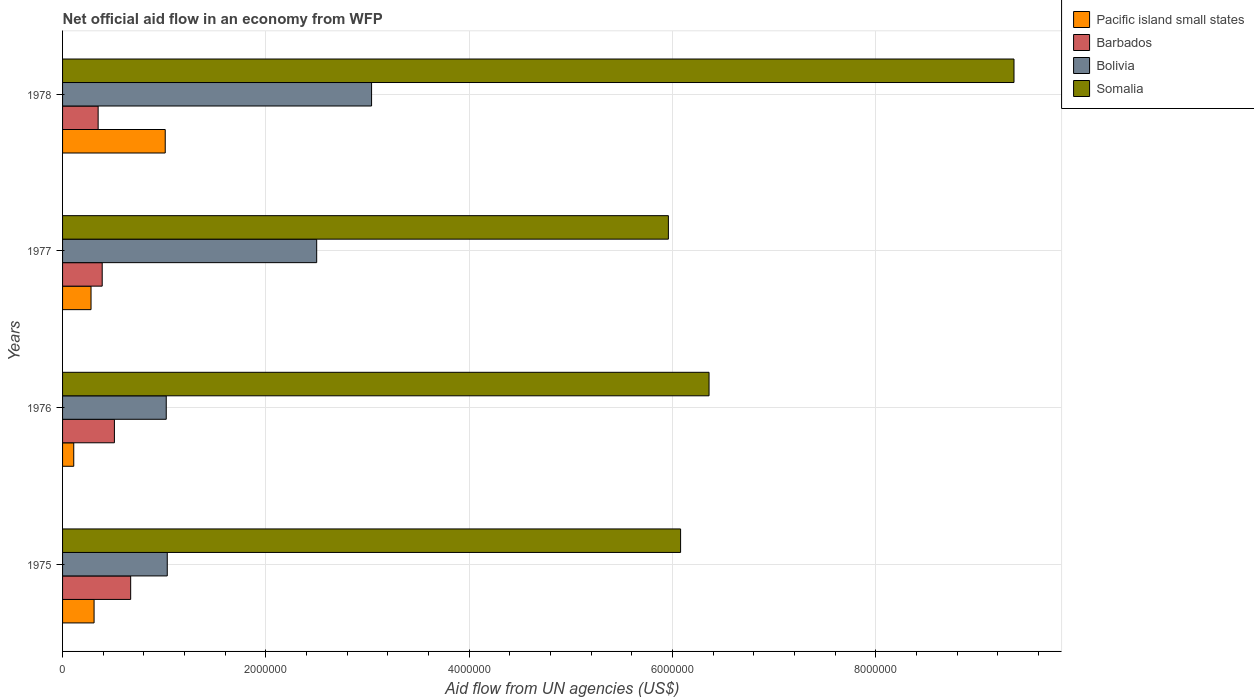How many different coloured bars are there?
Ensure brevity in your answer.  4. How many groups of bars are there?
Give a very brief answer. 4. How many bars are there on the 1st tick from the top?
Offer a very short reply. 4. How many bars are there on the 4th tick from the bottom?
Offer a terse response. 4. What is the label of the 1st group of bars from the top?
Offer a very short reply. 1978. In how many cases, is the number of bars for a given year not equal to the number of legend labels?
Your answer should be very brief. 0. What is the net official aid flow in Bolivia in 1978?
Ensure brevity in your answer.  3.04e+06. Across all years, what is the maximum net official aid flow in Somalia?
Offer a terse response. 9.36e+06. In which year was the net official aid flow in Barbados maximum?
Give a very brief answer. 1975. In which year was the net official aid flow in Pacific island small states minimum?
Provide a succinct answer. 1976. What is the total net official aid flow in Bolivia in the graph?
Ensure brevity in your answer.  7.59e+06. What is the difference between the net official aid flow in Barbados in 1975 and the net official aid flow in Bolivia in 1976?
Keep it short and to the point. -3.50e+05. What is the average net official aid flow in Bolivia per year?
Offer a terse response. 1.90e+06. In the year 1976, what is the difference between the net official aid flow in Bolivia and net official aid flow in Pacific island small states?
Offer a very short reply. 9.10e+05. In how many years, is the net official aid flow in Bolivia greater than 1200000 US$?
Ensure brevity in your answer.  2. What is the ratio of the net official aid flow in Somalia in 1975 to that in 1976?
Keep it short and to the point. 0.96. Is the difference between the net official aid flow in Bolivia in 1976 and 1977 greater than the difference between the net official aid flow in Pacific island small states in 1976 and 1977?
Ensure brevity in your answer.  No. What is the difference between the highest and the second highest net official aid flow in Bolivia?
Provide a succinct answer. 5.40e+05. What is the difference between the highest and the lowest net official aid flow in Bolivia?
Your answer should be compact. 2.02e+06. What does the 1st bar from the top in 1977 represents?
Your answer should be very brief. Somalia. What does the 4th bar from the bottom in 1976 represents?
Offer a terse response. Somalia. Is it the case that in every year, the sum of the net official aid flow in Somalia and net official aid flow in Barbados is greater than the net official aid flow in Pacific island small states?
Give a very brief answer. Yes. How many bars are there?
Provide a short and direct response. 16. How many years are there in the graph?
Provide a short and direct response. 4. What is the difference between two consecutive major ticks on the X-axis?
Provide a succinct answer. 2.00e+06. Does the graph contain grids?
Your answer should be very brief. Yes. How many legend labels are there?
Keep it short and to the point. 4. How are the legend labels stacked?
Give a very brief answer. Vertical. What is the title of the graph?
Your answer should be compact. Net official aid flow in an economy from WFP. What is the label or title of the X-axis?
Give a very brief answer. Aid flow from UN agencies (US$). What is the label or title of the Y-axis?
Make the answer very short. Years. What is the Aid flow from UN agencies (US$) of Barbados in 1975?
Your response must be concise. 6.70e+05. What is the Aid flow from UN agencies (US$) in Bolivia in 1975?
Make the answer very short. 1.03e+06. What is the Aid flow from UN agencies (US$) in Somalia in 1975?
Provide a short and direct response. 6.08e+06. What is the Aid flow from UN agencies (US$) of Barbados in 1976?
Ensure brevity in your answer.  5.10e+05. What is the Aid flow from UN agencies (US$) of Bolivia in 1976?
Offer a terse response. 1.02e+06. What is the Aid flow from UN agencies (US$) of Somalia in 1976?
Offer a terse response. 6.36e+06. What is the Aid flow from UN agencies (US$) of Barbados in 1977?
Keep it short and to the point. 3.90e+05. What is the Aid flow from UN agencies (US$) of Bolivia in 1977?
Your response must be concise. 2.50e+06. What is the Aid flow from UN agencies (US$) in Somalia in 1977?
Your response must be concise. 5.96e+06. What is the Aid flow from UN agencies (US$) in Pacific island small states in 1978?
Offer a terse response. 1.01e+06. What is the Aid flow from UN agencies (US$) in Bolivia in 1978?
Offer a terse response. 3.04e+06. What is the Aid flow from UN agencies (US$) of Somalia in 1978?
Offer a terse response. 9.36e+06. Across all years, what is the maximum Aid flow from UN agencies (US$) in Pacific island small states?
Provide a short and direct response. 1.01e+06. Across all years, what is the maximum Aid flow from UN agencies (US$) in Barbados?
Your response must be concise. 6.70e+05. Across all years, what is the maximum Aid flow from UN agencies (US$) in Bolivia?
Give a very brief answer. 3.04e+06. Across all years, what is the maximum Aid flow from UN agencies (US$) in Somalia?
Keep it short and to the point. 9.36e+06. Across all years, what is the minimum Aid flow from UN agencies (US$) of Bolivia?
Your answer should be compact. 1.02e+06. Across all years, what is the minimum Aid flow from UN agencies (US$) in Somalia?
Offer a terse response. 5.96e+06. What is the total Aid flow from UN agencies (US$) of Pacific island small states in the graph?
Give a very brief answer. 1.71e+06. What is the total Aid flow from UN agencies (US$) in Barbados in the graph?
Ensure brevity in your answer.  1.92e+06. What is the total Aid flow from UN agencies (US$) of Bolivia in the graph?
Offer a very short reply. 7.59e+06. What is the total Aid flow from UN agencies (US$) in Somalia in the graph?
Provide a short and direct response. 2.78e+07. What is the difference between the Aid flow from UN agencies (US$) of Pacific island small states in 1975 and that in 1976?
Your answer should be very brief. 2.00e+05. What is the difference between the Aid flow from UN agencies (US$) in Somalia in 1975 and that in 1976?
Your answer should be very brief. -2.80e+05. What is the difference between the Aid flow from UN agencies (US$) of Bolivia in 1975 and that in 1977?
Your answer should be compact. -1.47e+06. What is the difference between the Aid flow from UN agencies (US$) of Pacific island small states in 1975 and that in 1978?
Offer a very short reply. -7.00e+05. What is the difference between the Aid flow from UN agencies (US$) of Barbados in 1975 and that in 1978?
Offer a terse response. 3.20e+05. What is the difference between the Aid flow from UN agencies (US$) of Bolivia in 1975 and that in 1978?
Provide a succinct answer. -2.01e+06. What is the difference between the Aid flow from UN agencies (US$) in Somalia in 1975 and that in 1978?
Make the answer very short. -3.28e+06. What is the difference between the Aid flow from UN agencies (US$) in Bolivia in 1976 and that in 1977?
Your answer should be compact. -1.48e+06. What is the difference between the Aid flow from UN agencies (US$) of Somalia in 1976 and that in 1977?
Provide a short and direct response. 4.00e+05. What is the difference between the Aid flow from UN agencies (US$) of Pacific island small states in 1976 and that in 1978?
Make the answer very short. -9.00e+05. What is the difference between the Aid flow from UN agencies (US$) in Barbados in 1976 and that in 1978?
Offer a terse response. 1.60e+05. What is the difference between the Aid flow from UN agencies (US$) in Bolivia in 1976 and that in 1978?
Your response must be concise. -2.02e+06. What is the difference between the Aid flow from UN agencies (US$) in Pacific island small states in 1977 and that in 1978?
Your answer should be compact. -7.30e+05. What is the difference between the Aid flow from UN agencies (US$) in Bolivia in 1977 and that in 1978?
Your response must be concise. -5.40e+05. What is the difference between the Aid flow from UN agencies (US$) of Somalia in 1977 and that in 1978?
Your answer should be very brief. -3.40e+06. What is the difference between the Aid flow from UN agencies (US$) in Pacific island small states in 1975 and the Aid flow from UN agencies (US$) in Bolivia in 1976?
Offer a very short reply. -7.10e+05. What is the difference between the Aid flow from UN agencies (US$) in Pacific island small states in 1975 and the Aid flow from UN agencies (US$) in Somalia in 1976?
Your answer should be very brief. -6.05e+06. What is the difference between the Aid flow from UN agencies (US$) of Barbados in 1975 and the Aid flow from UN agencies (US$) of Bolivia in 1976?
Offer a very short reply. -3.50e+05. What is the difference between the Aid flow from UN agencies (US$) in Barbados in 1975 and the Aid flow from UN agencies (US$) in Somalia in 1976?
Provide a short and direct response. -5.69e+06. What is the difference between the Aid flow from UN agencies (US$) of Bolivia in 1975 and the Aid flow from UN agencies (US$) of Somalia in 1976?
Make the answer very short. -5.33e+06. What is the difference between the Aid flow from UN agencies (US$) in Pacific island small states in 1975 and the Aid flow from UN agencies (US$) in Bolivia in 1977?
Offer a very short reply. -2.19e+06. What is the difference between the Aid flow from UN agencies (US$) of Pacific island small states in 1975 and the Aid flow from UN agencies (US$) of Somalia in 1977?
Your response must be concise. -5.65e+06. What is the difference between the Aid flow from UN agencies (US$) of Barbados in 1975 and the Aid flow from UN agencies (US$) of Bolivia in 1977?
Offer a very short reply. -1.83e+06. What is the difference between the Aid flow from UN agencies (US$) of Barbados in 1975 and the Aid flow from UN agencies (US$) of Somalia in 1977?
Make the answer very short. -5.29e+06. What is the difference between the Aid flow from UN agencies (US$) in Bolivia in 1975 and the Aid flow from UN agencies (US$) in Somalia in 1977?
Ensure brevity in your answer.  -4.93e+06. What is the difference between the Aid flow from UN agencies (US$) of Pacific island small states in 1975 and the Aid flow from UN agencies (US$) of Bolivia in 1978?
Make the answer very short. -2.73e+06. What is the difference between the Aid flow from UN agencies (US$) of Pacific island small states in 1975 and the Aid flow from UN agencies (US$) of Somalia in 1978?
Ensure brevity in your answer.  -9.05e+06. What is the difference between the Aid flow from UN agencies (US$) of Barbados in 1975 and the Aid flow from UN agencies (US$) of Bolivia in 1978?
Provide a short and direct response. -2.37e+06. What is the difference between the Aid flow from UN agencies (US$) in Barbados in 1975 and the Aid flow from UN agencies (US$) in Somalia in 1978?
Your response must be concise. -8.69e+06. What is the difference between the Aid flow from UN agencies (US$) in Bolivia in 1975 and the Aid flow from UN agencies (US$) in Somalia in 1978?
Provide a succinct answer. -8.33e+06. What is the difference between the Aid flow from UN agencies (US$) in Pacific island small states in 1976 and the Aid flow from UN agencies (US$) in Barbados in 1977?
Your response must be concise. -2.80e+05. What is the difference between the Aid flow from UN agencies (US$) in Pacific island small states in 1976 and the Aid flow from UN agencies (US$) in Bolivia in 1977?
Offer a very short reply. -2.39e+06. What is the difference between the Aid flow from UN agencies (US$) of Pacific island small states in 1976 and the Aid flow from UN agencies (US$) of Somalia in 1977?
Your answer should be compact. -5.85e+06. What is the difference between the Aid flow from UN agencies (US$) in Barbados in 1976 and the Aid flow from UN agencies (US$) in Bolivia in 1977?
Keep it short and to the point. -1.99e+06. What is the difference between the Aid flow from UN agencies (US$) of Barbados in 1976 and the Aid flow from UN agencies (US$) of Somalia in 1977?
Provide a short and direct response. -5.45e+06. What is the difference between the Aid flow from UN agencies (US$) of Bolivia in 1976 and the Aid flow from UN agencies (US$) of Somalia in 1977?
Offer a very short reply. -4.94e+06. What is the difference between the Aid flow from UN agencies (US$) in Pacific island small states in 1976 and the Aid flow from UN agencies (US$) in Bolivia in 1978?
Offer a terse response. -2.93e+06. What is the difference between the Aid flow from UN agencies (US$) in Pacific island small states in 1976 and the Aid flow from UN agencies (US$) in Somalia in 1978?
Your answer should be very brief. -9.25e+06. What is the difference between the Aid flow from UN agencies (US$) in Barbados in 1976 and the Aid flow from UN agencies (US$) in Bolivia in 1978?
Your answer should be very brief. -2.53e+06. What is the difference between the Aid flow from UN agencies (US$) in Barbados in 1976 and the Aid flow from UN agencies (US$) in Somalia in 1978?
Offer a very short reply. -8.85e+06. What is the difference between the Aid flow from UN agencies (US$) in Bolivia in 1976 and the Aid flow from UN agencies (US$) in Somalia in 1978?
Your response must be concise. -8.34e+06. What is the difference between the Aid flow from UN agencies (US$) in Pacific island small states in 1977 and the Aid flow from UN agencies (US$) in Bolivia in 1978?
Keep it short and to the point. -2.76e+06. What is the difference between the Aid flow from UN agencies (US$) in Pacific island small states in 1977 and the Aid flow from UN agencies (US$) in Somalia in 1978?
Your answer should be very brief. -9.08e+06. What is the difference between the Aid flow from UN agencies (US$) of Barbados in 1977 and the Aid flow from UN agencies (US$) of Bolivia in 1978?
Your answer should be very brief. -2.65e+06. What is the difference between the Aid flow from UN agencies (US$) in Barbados in 1977 and the Aid flow from UN agencies (US$) in Somalia in 1978?
Give a very brief answer. -8.97e+06. What is the difference between the Aid flow from UN agencies (US$) of Bolivia in 1977 and the Aid flow from UN agencies (US$) of Somalia in 1978?
Your response must be concise. -6.86e+06. What is the average Aid flow from UN agencies (US$) of Pacific island small states per year?
Provide a succinct answer. 4.28e+05. What is the average Aid flow from UN agencies (US$) in Bolivia per year?
Ensure brevity in your answer.  1.90e+06. What is the average Aid flow from UN agencies (US$) of Somalia per year?
Give a very brief answer. 6.94e+06. In the year 1975, what is the difference between the Aid flow from UN agencies (US$) of Pacific island small states and Aid flow from UN agencies (US$) of Barbados?
Make the answer very short. -3.60e+05. In the year 1975, what is the difference between the Aid flow from UN agencies (US$) of Pacific island small states and Aid flow from UN agencies (US$) of Bolivia?
Your response must be concise. -7.20e+05. In the year 1975, what is the difference between the Aid flow from UN agencies (US$) in Pacific island small states and Aid flow from UN agencies (US$) in Somalia?
Ensure brevity in your answer.  -5.77e+06. In the year 1975, what is the difference between the Aid flow from UN agencies (US$) of Barbados and Aid flow from UN agencies (US$) of Bolivia?
Your response must be concise. -3.60e+05. In the year 1975, what is the difference between the Aid flow from UN agencies (US$) of Barbados and Aid flow from UN agencies (US$) of Somalia?
Make the answer very short. -5.41e+06. In the year 1975, what is the difference between the Aid flow from UN agencies (US$) of Bolivia and Aid flow from UN agencies (US$) of Somalia?
Make the answer very short. -5.05e+06. In the year 1976, what is the difference between the Aid flow from UN agencies (US$) of Pacific island small states and Aid flow from UN agencies (US$) of Barbados?
Make the answer very short. -4.00e+05. In the year 1976, what is the difference between the Aid flow from UN agencies (US$) in Pacific island small states and Aid flow from UN agencies (US$) in Bolivia?
Ensure brevity in your answer.  -9.10e+05. In the year 1976, what is the difference between the Aid flow from UN agencies (US$) of Pacific island small states and Aid flow from UN agencies (US$) of Somalia?
Ensure brevity in your answer.  -6.25e+06. In the year 1976, what is the difference between the Aid flow from UN agencies (US$) in Barbados and Aid flow from UN agencies (US$) in Bolivia?
Your answer should be compact. -5.10e+05. In the year 1976, what is the difference between the Aid flow from UN agencies (US$) of Barbados and Aid flow from UN agencies (US$) of Somalia?
Your answer should be compact. -5.85e+06. In the year 1976, what is the difference between the Aid flow from UN agencies (US$) of Bolivia and Aid flow from UN agencies (US$) of Somalia?
Keep it short and to the point. -5.34e+06. In the year 1977, what is the difference between the Aid flow from UN agencies (US$) in Pacific island small states and Aid flow from UN agencies (US$) in Barbados?
Provide a succinct answer. -1.10e+05. In the year 1977, what is the difference between the Aid flow from UN agencies (US$) of Pacific island small states and Aid flow from UN agencies (US$) of Bolivia?
Offer a terse response. -2.22e+06. In the year 1977, what is the difference between the Aid flow from UN agencies (US$) of Pacific island small states and Aid flow from UN agencies (US$) of Somalia?
Give a very brief answer. -5.68e+06. In the year 1977, what is the difference between the Aid flow from UN agencies (US$) of Barbados and Aid flow from UN agencies (US$) of Bolivia?
Give a very brief answer. -2.11e+06. In the year 1977, what is the difference between the Aid flow from UN agencies (US$) of Barbados and Aid flow from UN agencies (US$) of Somalia?
Your response must be concise. -5.57e+06. In the year 1977, what is the difference between the Aid flow from UN agencies (US$) of Bolivia and Aid flow from UN agencies (US$) of Somalia?
Provide a short and direct response. -3.46e+06. In the year 1978, what is the difference between the Aid flow from UN agencies (US$) in Pacific island small states and Aid flow from UN agencies (US$) in Bolivia?
Keep it short and to the point. -2.03e+06. In the year 1978, what is the difference between the Aid flow from UN agencies (US$) in Pacific island small states and Aid flow from UN agencies (US$) in Somalia?
Provide a succinct answer. -8.35e+06. In the year 1978, what is the difference between the Aid flow from UN agencies (US$) in Barbados and Aid flow from UN agencies (US$) in Bolivia?
Offer a terse response. -2.69e+06. In the year 1978, what is the difference between the Aid flow from UN agencies (US$) of Barbados and Aid flow from UN agencies (US$) of Somalia?
Ensure brevity in your answer.  -9.01e+06. In the year 1978, what is the difference between the Aid flow from UN agencies (US$) in Bolivia and Aid flow from UN agencies (US$) in Somalia?
Ensure brevity in your answer.  -6.32e+06. What is the ratio of the Aid flow from UN agencies (US$) in Pacific island small states in 1975 to that in 1976?
Provide a short and direct response. 2.82. What is the ratio of the Aid flow from UN agencies (US$) of Barbados in 1975 to that in 1976?
Provide a succinct answer. 1.31. What is the ratio of the Aid flow from UN agencies (US$) of Bolivia in 1975 to that in 1976?
Your response must be concise. 1.01. What is the ratio of the Aid flow from UN agencies (US$) of Somalia in 1975 to that in 1976?
Your response must be concise. 0.96. What is the ratio of the Aid flow from UN agencies (US$) of Pacific island small states in 1975 to that in 1977?
Give a very brief answer. 1.11. What is the ratio of the Aid flow from UN agencies (US$) of Barbados in 1975 to that in 1977?
Make the answer very short. 1.72. What is the ratio of the Aid flow from UN agencies (US$) in Bolivia in 1975 to that in 1977?
Keep it short and to the point. 0.41. What is the ratio of the Aid flow from UN agencies (US$) of Somalia in 1975 to that in 1977?
Make the answer very short. 1.02. What is the ratio of the Aid flow from UN agencies (US$) in Pacific island small states in 1975 to that in 1978?
Your response must be concise. 0.31. What is the ratio of the Aid flow from UN agencies (US$) in Barbados in 1975 to that in 1978?
Your response must be concise. 1.91. What is the ratio of the Aid flow from UN agencies (US$) in Bolivia in 1975 to that in 1978?
Ensure brevity in your answer.  0.34. What is the ratio of the Aid flow from UN agencies (US$) in Somalia in 1975 to that in 1978?
Provide a succinct answer. 0.65. What is the ratio of the Aid flow from UN agencies (US$) of Pacific island small states in 1976 to that in 1977?
Give a very brief answer. 0.39. What is the ratio of the Aid flow from UN agencies (US$) in Barbados in 1976 to that in 1977?
Your response must be concise. 1.31. What is the ratio of the Aid flow from UN agencies (US$) of Bolivia in 1976 to that in 1977?
Your response must be concise. 0.41. What is the ratio of the Aid flow from UN agencies (US$) of Somalia in 1976 to that in 1977?
Keep it short and to the point. 1.07. What is the ratio of the Aid flow from UN agencies (US$) in Pacific island small states in 1976 to that in 1978?
Make the answer very short. 0.11. What is the ratio of the Aid flow from UN agencies (US$) in Barbados in 1976 to that in 1978?
Offer a very short reply. 1.46. What is the ratio of the Aid flow from UN agencies (US$) in Bolivia in 1976 to that in 1978?
Your response must be concise. 0.34. What is the ratio of the Aid flow from UN agencies (US$) in Somalia in 1976 to that in 1978?
Provide a succinct answer. 0.68. What is the ratio of the Aid flow from UN agencies (US$) in Pacific island small states in 1977 to that in 1978?
Provide a short and direct response. 0.28. What is the ratio of the Aid flow from UN agencies (US$) in Barbados in 1977 to that in 1978?
Your answer should be compact. 1.11. What is the ratio of the Aid flow from UN agencies (US$) in Bolivia in 1977 to that in 1978?
Provide a short and direct response. 0.82. What is the ratio of the Aid flow from UN agencies (US$) in Somalia in 1977 to that in 1978?
Give a very brief answer. 0.64. What is the difference between the highest and the second highest Aid flow from UN agencies (US$) of Pacific island small states?
Ensure brevity in your answer.  7.00e+05. What is the difference between the highest and the second highest Aid flow from UN agencies (US$) in Bolivia?
Offer a terse response. 5.40e+05. What is the difference between the highest and the lowest Aid flow from UN agencies (US$) of Barbados?
Offer a terse response. 3.20e+05. What is the difference between the highest and the lowest Aid flow from UN agencies (US$) in Bolivia?
Your response must be concise. 2.02e+06. What is the difference between the highest and the lowest Aid flow from UN agencies (US$) of Somalia?
Offer a terse response. 3.40e+06. 